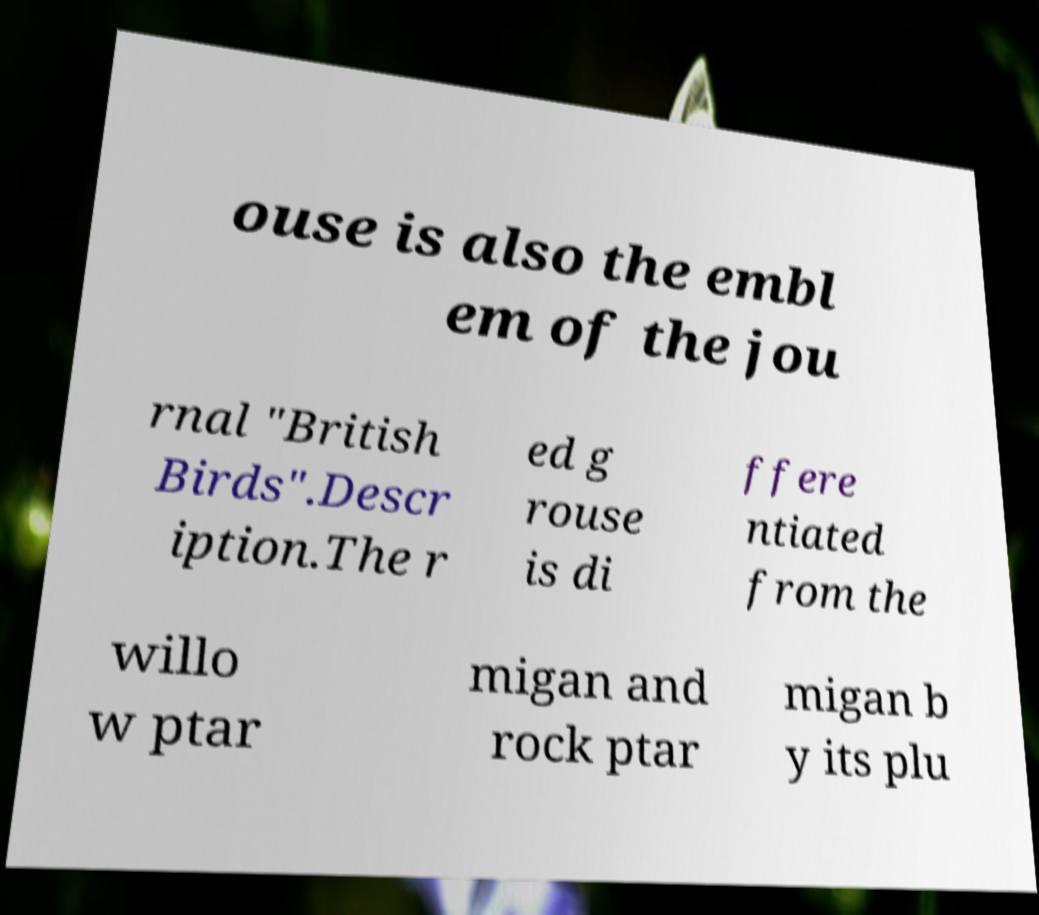What messages or text are displayed in this image? I need them in a readable, typed format. ouse is also the embl em of the jou rnal "British Birds".Descr iption.The r ed g rouse is di ffere ntiated from the willo w ptar migan and rock ptar migan b y its plu 